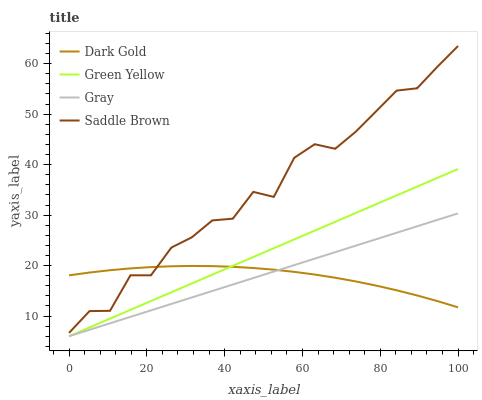Does Dark Gold have the minimum area under the curve?
Answer yes or no. Yes. Does Saddle Brown have the maximum area under the curve?
Answer yes or no. Yes. Does Green Yellow have the minimum area under the curve?
Answer yes or no. No. Does Green Yellow have the maximum area under the curve?
Answer yes or no. No. Is Gray the smoothest?
Answer yes or no. Yes. Is Saddle Brown the roughest?
Answer yes or no. Yes. Is Green Yellow the smoothest?
Answer yes or no. No. Is Green Yellow the roughest?
Answer yes or no. No. Does Saddle Brown have the lowest value?
Answer yes or no. No. Does Saddle Brown have the highest value?
Answer yes or no. Yes. Does Green Yellow have the highest value?
Answer yes or no. No. Is Green Yellow less than Saddle Brown?
Answer yes or no. Yes. Is Saddle Brown greater than Green Yellow?
Answer yes or no. Yes. Does Gray intersect Dark Gold?
Answer yes or no. Yes. Is Gray less than Dark Gold?
Answer yes or no. No. Is Gray greater than Dark Gold?
Answer yes or no. No. Does Green Yellow intersect Saddle Brown?
Answer yes or no. No. 